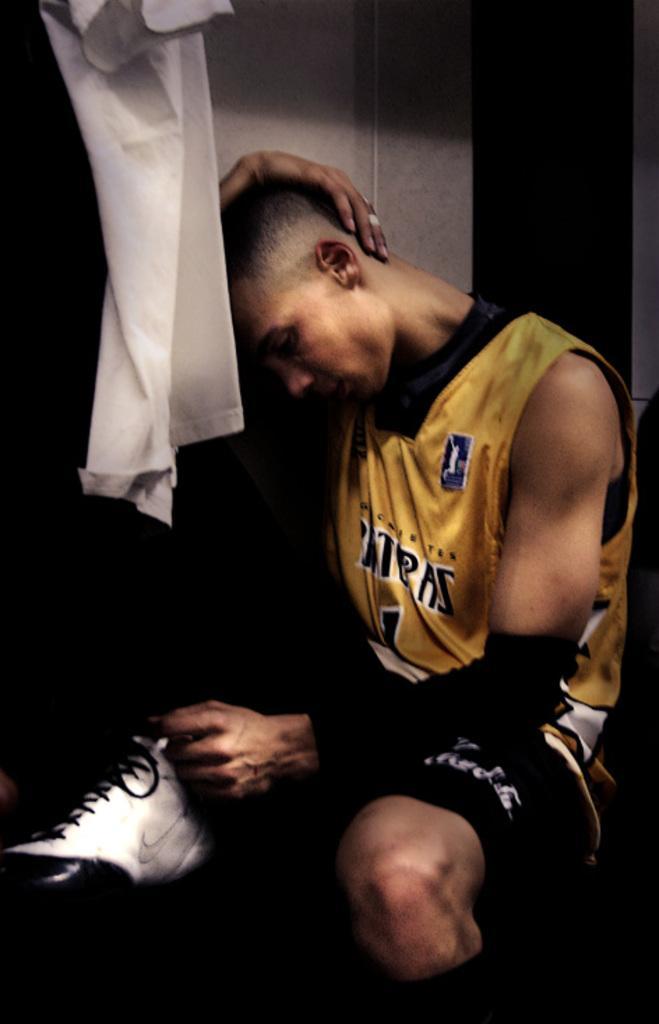How would you summarize this image in a sentence or two? In the foreground of this image, there is a man sitting with one hand on his head. On the left top, there is a cloth and the wall behind him. 